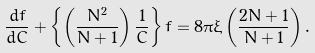Convert formula to latex. <formula><loc_0><loc_0><loc_500><loc_500>\frac { d f } { d C } + \left \{ \left ( \frac { N ^ { 2 } } { N + 1 } \right ) \frac { 1 } { C } \right \} f = 8 \pi \xi \left ( \frac { 2 N + 1 } { N + 1 } \right ) .</formula> 